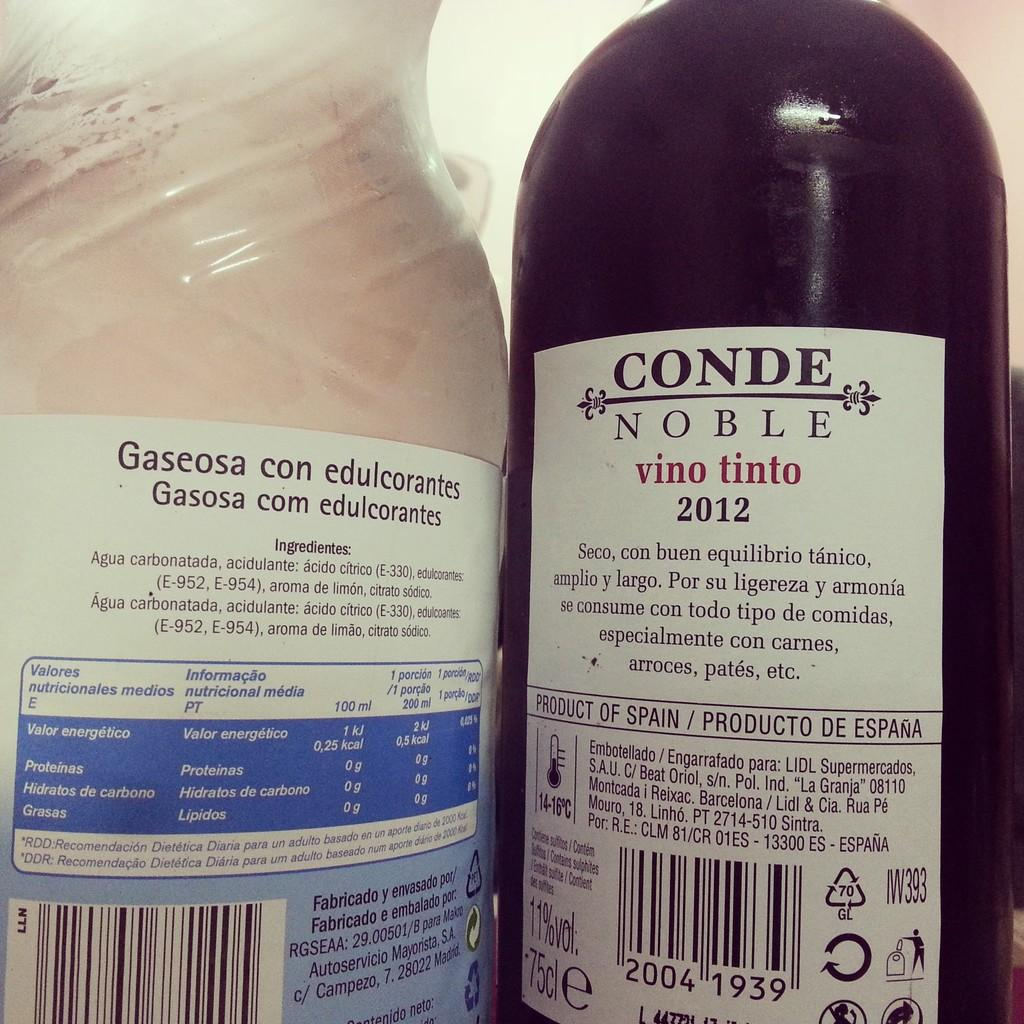<image>
Render a clear and concise summary of the photo. Two bottles one of Conde Noble Vino Tinto 2012. 